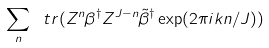Convert formula to latex. <formula><loc_0><loc_0><loc_500><loc_500>\sum _ { n } \ t r ( Z ^ { n } \beta ^ { \dagger } Z ^ { J - n } \tilde { \beta } ^ { \dagger } \exp ( 2 \pi i k n / J ) )</formula> 